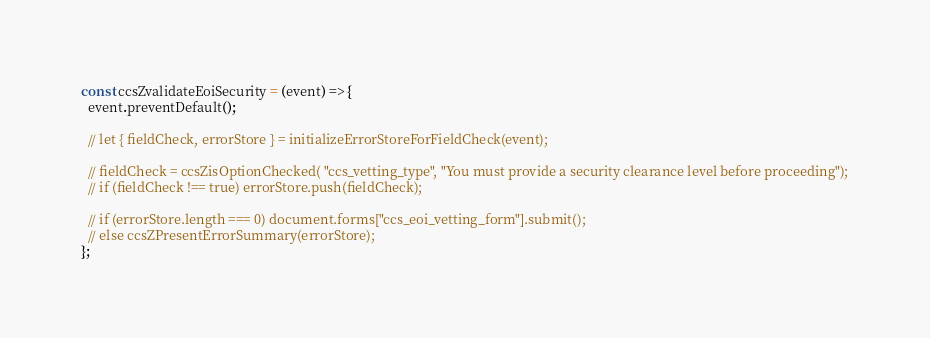<code> <loc_0><loc_0><loc_500><loc_500><_JavaScript_>const ccsZvalidateEoiSecurity = (event) => {
  event.preventDefault();

  // let { fieldCheck, errorStore } = initializeErrorStoreForFieldCheck(event);

  // fieldCheck = ccsZisOptionChecked( "ccs_vetting_type", "You must provide a security clearance level before proceeding");
  // if (fieldCheck !== true) errorStore.push(fieldCheck);

  // if (errorStore.length === 0) document.forms["ccs_eoi_vetting_form"].submit();
  // else ccsZPresentErrorSummary(errorStore);
};
</code> 